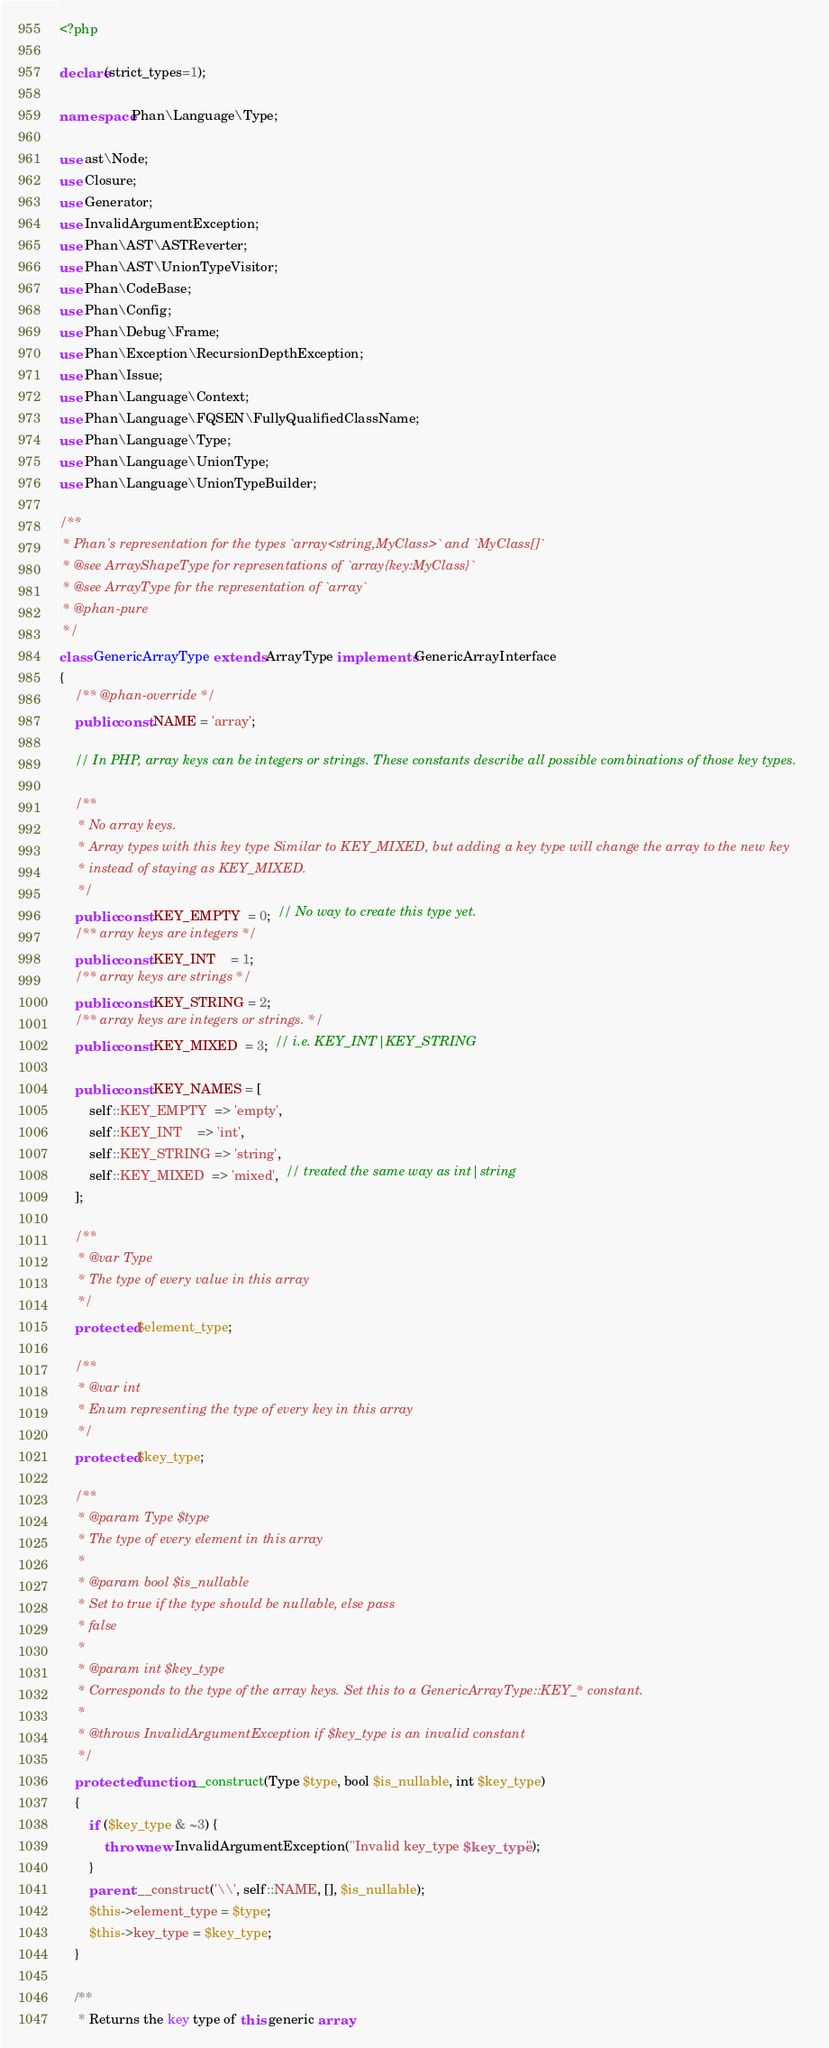<code> <loc_0><loc_0><loc_500><loc_500><_PHP_><?php

declare(strict_types=1);

namespace Phan\Language\Type;

use ast\Node;
use Closure;
use Generator;
use InvalidArgumentException;
use Phan\AST\ASTReverter;
use Phan\AST\UnionTypeVisitor;
use Phan\CodeBase;
use Phan\Config;
use Phan\Debug\Frame;
use Phan\Exception\RecursionDepthException;
use Phan\Issue;
use Phan\Language\Context;
use Phan\Language\FQSEN\FullyQualifiedClassName;
use Phan\Language\Type;
use Phan\Language\UnionType;
use Phan\Language\UnionTypeBuilder;

/**
 * Phan's representation for the types `array<string,MyClass>` and `MyClass[]`
 * @see ArrayShapeType for representations of `array{key:MyClass}`
 * @see ArrayType for the representation of `array`
 * @phan-pure
 */
class GenericArrayType extends ArrayType implements GenericArrayInterface
{
    /** @phan-override */
    public const NAME = 'array';

    // In PHP, array keys can be integers or strings. These constants describe all possible combinations of those key types.

    /**
     * No array keys.
     * Array types with this key type Similar to KEY_MIXED, but adding a key type will change the array to the new key
     * instead of staying as KEY_MIXED.
     */
    public const KEY_EMPTY  = 0;  // No way to create this type yet.
    /** array keys are integers */
    public const KEY_INT    = 1;
    /** array keys are strings */
    public const KEY_STRING = 2;
    /** array keys are integers or strings. */
    public const KEY_MIXED  = 3;  // i.e. KEY_INT|KEY_STRING

    public const KEY_NAMES = [
        self::KEY_EMPTY  => 'empty',
        self::KEY_INT    => 'int',
        self::KEY_STRING => 'string',
        self::KEY_MIXED  => 'mixed',  // treated the same way as int|string
    ];

    /**
     * @var Type
     * The type of every value in this array
     */
    protected $element_type;

    /**
     * @var int
     * Enum representing the type of every key in this array
     */
    protected $key_type;

    /**
     * @param Type $type
     * The type of every element in this array
     *
     * @param bool $is_nullable
     * Set to true if the type should be nullable, else pass
     * false
     *
     * @param int $key_type
     * Corresponds to the type of the array keys. Set this to a GenericArrayType::KEY_* constant.
     *
     * @throws InvalidArgumentException if $key_type is an invalid constant
     */
    protected function __construct(Type $type, bool $is_nullable, int $key_type)
    {
        if ($key_type & ~3) {
            throw new InvalidArgumentException("Invalid key_type $key_type");
        }
        parent::__construct('\\', self::NAME, [], $is_nullable);
        $this->element_type = $type;
        $this->key_type = $key_type;
    }

    /**
     * Returns the key type of this generic array.</code> 